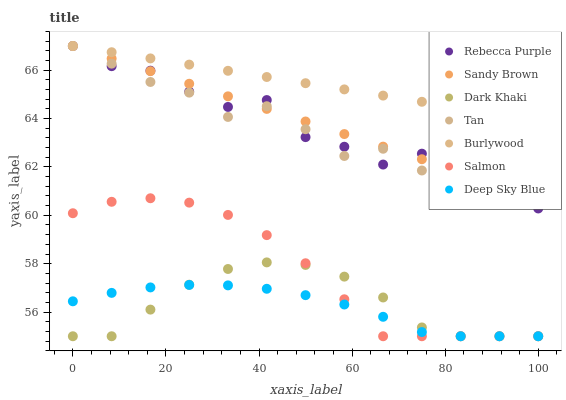Does Deep Sky Blue have the minimum area under the curve?
Answer yes or no. Yes. Does Burlywood have the maximum area under the curve?
Answer yes or no. Yes. Does Salmon have the minimum area under the curve?
Answer yes or no. No. Does Salmon have the maximum area under the curve?
Answer yes or no. No. Is Burlywood the smoothest?
Answer yes or no. Yes. Is Rebecca Purple the roughest?
Answer yes or no. Yes. Is Salmon the smoothest?
Answer yes or no. No. Is Salmon the roughest?
Answer yes or no. No. Does Salmon have the lowest value?
Answer yes or no. Yes. Does Rebecca Purple have the lowest value?
Answer yes or no. No. Does Sandy Brown have the highest value?
Answer yes or no. Yes. Does Salmon have the highest value?
Answer yes or no. No. Is Deep Sky Blue less than Tan?
Answer yes or no. Yes. Is Tan greater than Salmon?
Answer yes or no. Yes. Does Salmon intersect Deep Sky Blue?
Answer yes or no. Yes. Is Salmon less than Deep Sky Blue?
Answer yes or no. No. Is Salmon greater than Deep Sky Blue?
Answer yes or no. No. Does Deep Sky Blue intersect Tan?
Answer yes or no. No. 